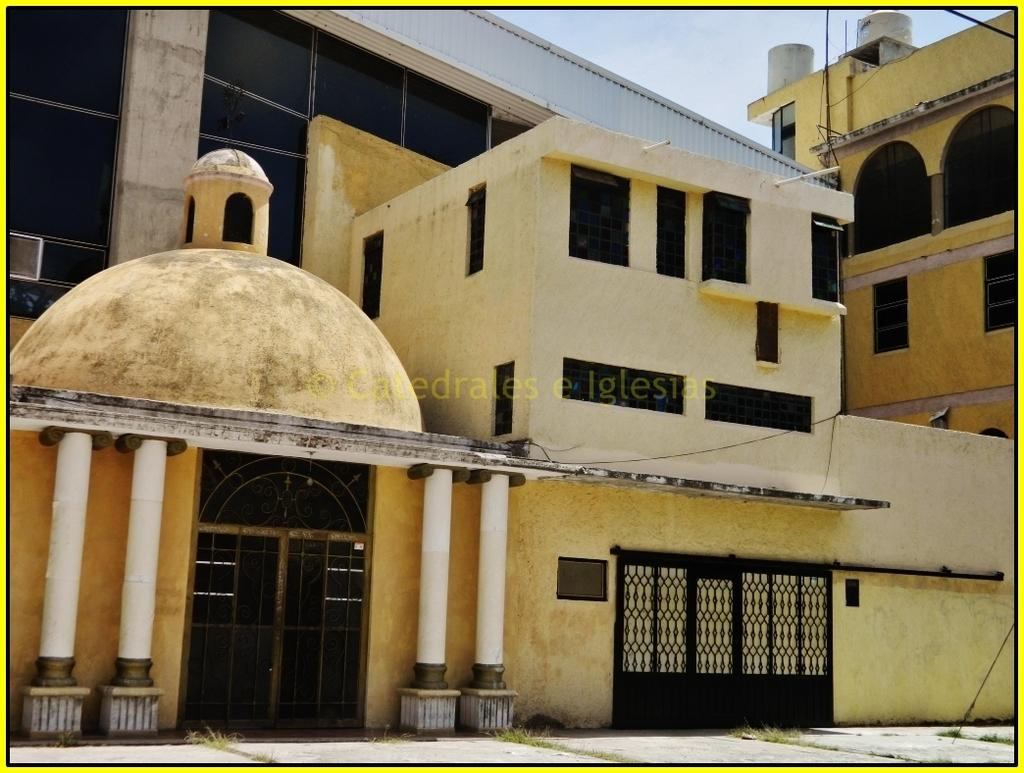What type of structure is present in the image? There is a building in the image. What feature can be seen at the entrance of the building? The building has a gate. What architectural elements are visible on the building? The building has windows and doors. What is visible at the top of the image? The sky is visible at the top of the image. What type of meal is being prepared in the building in the image? There is no indication of a meal being prepared in the building in the image. Can you tell me what letter is being written on the windows of the building? There is no indication of any letters being written on the windows of the building in the image. 